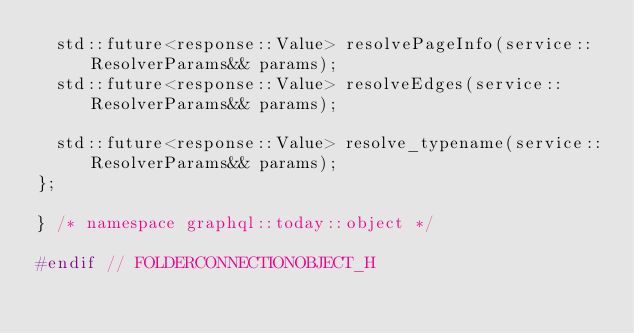Convert code to text. <code><loc_0><loc_0><loc_500><loc_500><_C_>	std::future<response::Value> resolvePageInfo(service::ResolverParams&& params);
	std::future<response::Value> resolveEdges(service::ResolverParams&& params);

	std::future<response::Value> resolve_typename(service::ResolverParams&& params);
};

} /* namespace graphql::today::object */

#endif // FOLDERCONNECTIONOBJECT_H
</code> 